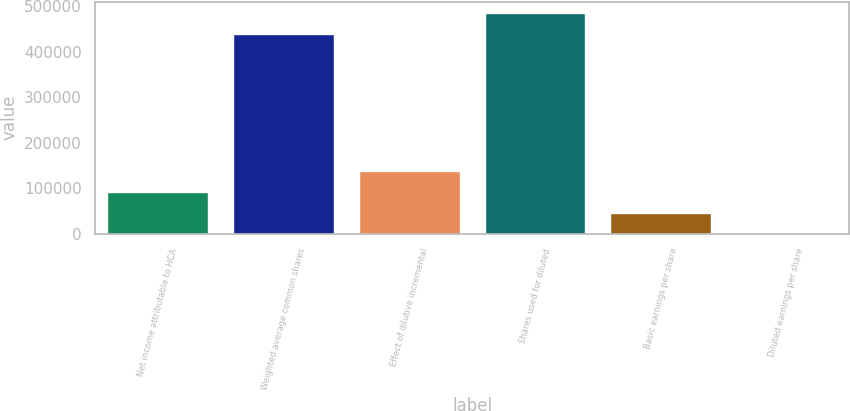Convert chart to OTSL. <chart><loc_0><loc_0><loc_500><loc_500><bar_chart><fcel>Net income attributable to HCA<fcel>Weighted average common shares<fcel>Effect of dilutive incremental<fcel>Shares used for diluted<fcel>Basic earnings per share<fcel>Diluted earnings per share<nl><fcel>91883.4<fcel>440178<fcel>137823<fcel>486118<fcel>45943.4<fcel>3.49<nl></chart> 